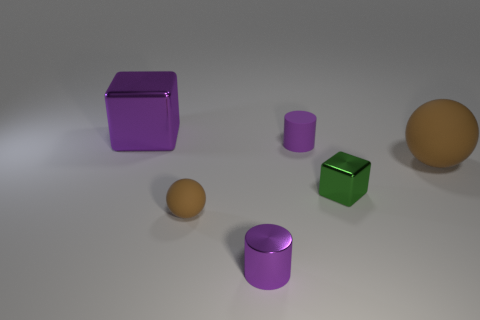Add 2 big brown matte objects. How many objects exist? 8 Subtract all cubes. How many objects are left? 4 Subtract 1 green cubes. How many objects are left? 5 Subtract all tiny metal cylinders. Subtract all small gray balls. How many objects are left? 5 Add 5 large brown balls. How many large brown balls are left? 6 Add 2 spheres. How many spheres exist? 4 